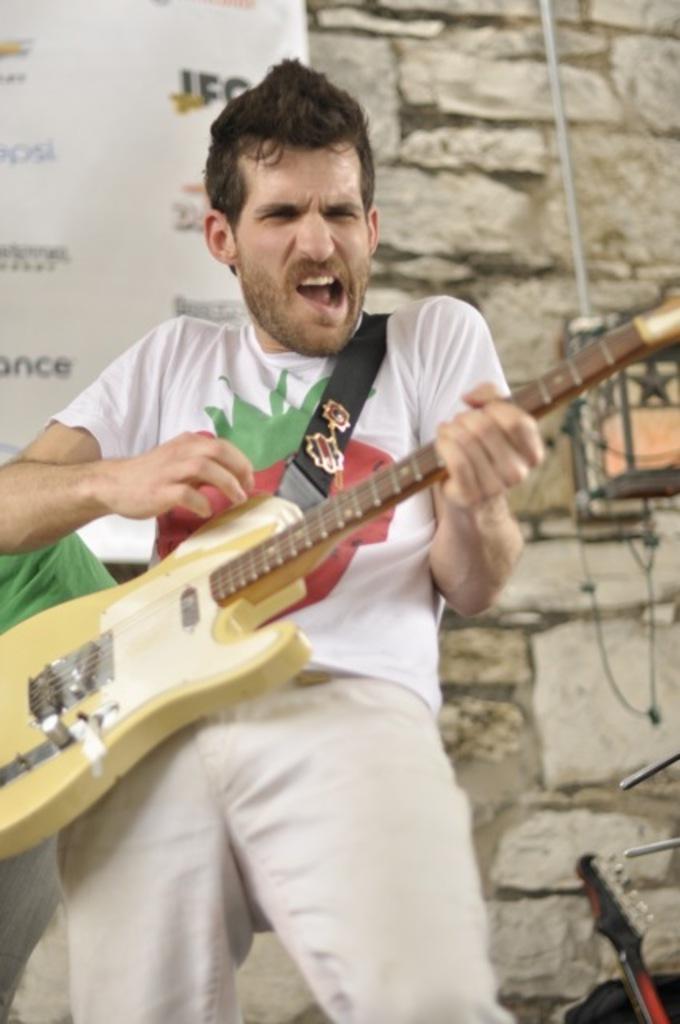Please provide a concise description of this image. In this picture a man is playing guitar, in the background we can see a hoarding and a wall, and also we can find couple of musical instruments. 